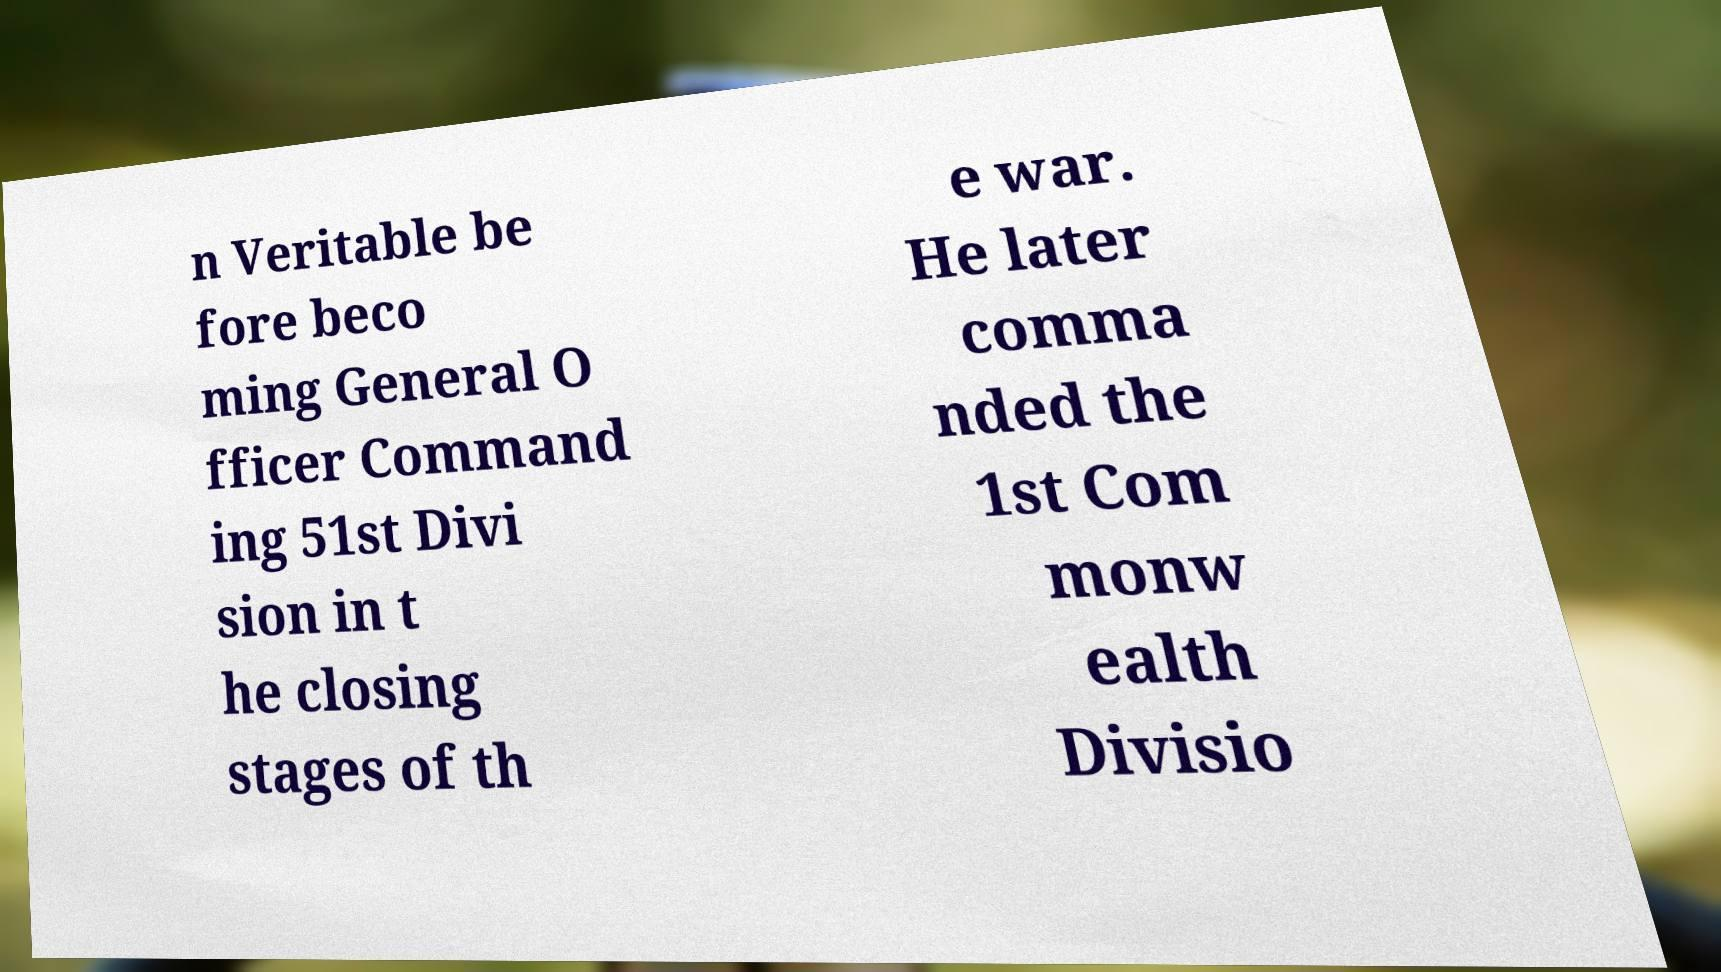Please read and relay the text visible in this image. What does it say? n Veritable be fore beco ming General O fficer Command ing 51st Divi sion in t he closing stages of th e war. He later comma nded the 1st Com monw ealth Divisio 